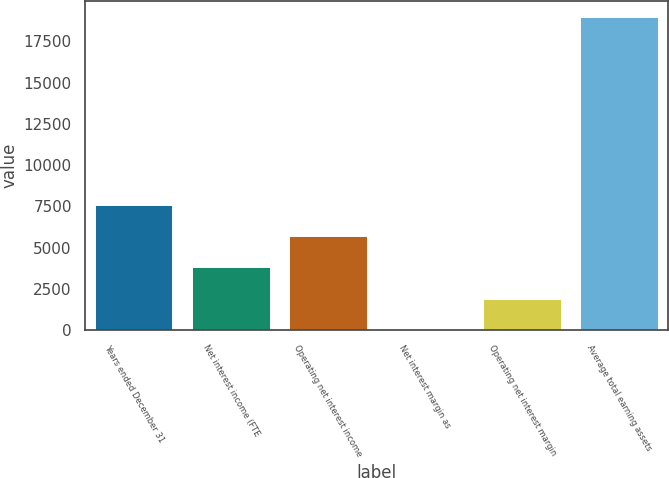Convert chart. <chart><loc_0><loc_0><loc_500><loc_500><bar_chart><fcel>Years ended December 31<fcel>Net interest income (FTE<fcel>Operating net interest income<fcel>Net interest margin as<fcel>Operating net interest margin<fcel>Average total earning assets<nl><fcel>7597.79<fcel>3800.73<fcel>5699.26<fcel>3.67<fcel>1902.2<fcel>18989<nl></chart> 